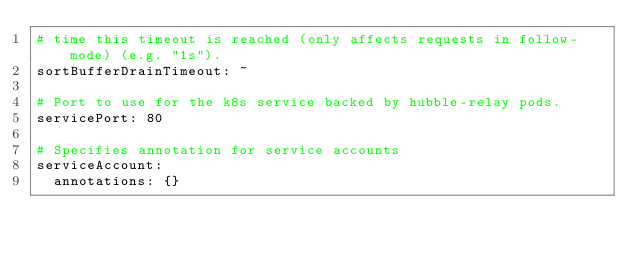<code> <loc_0><loc_0><loc_500><loc_500><_YAML_># time this timeout is reached (only affects requests in follow-mode) (e.g. "1s").
sortBufferDrainTimeout: ~

# Port to use for the k8s service backed by hubble-relay pods.
servicePort: 80

# Specifies annotation for service accounts
serviceAccount:
  annotations: {}
</code> 